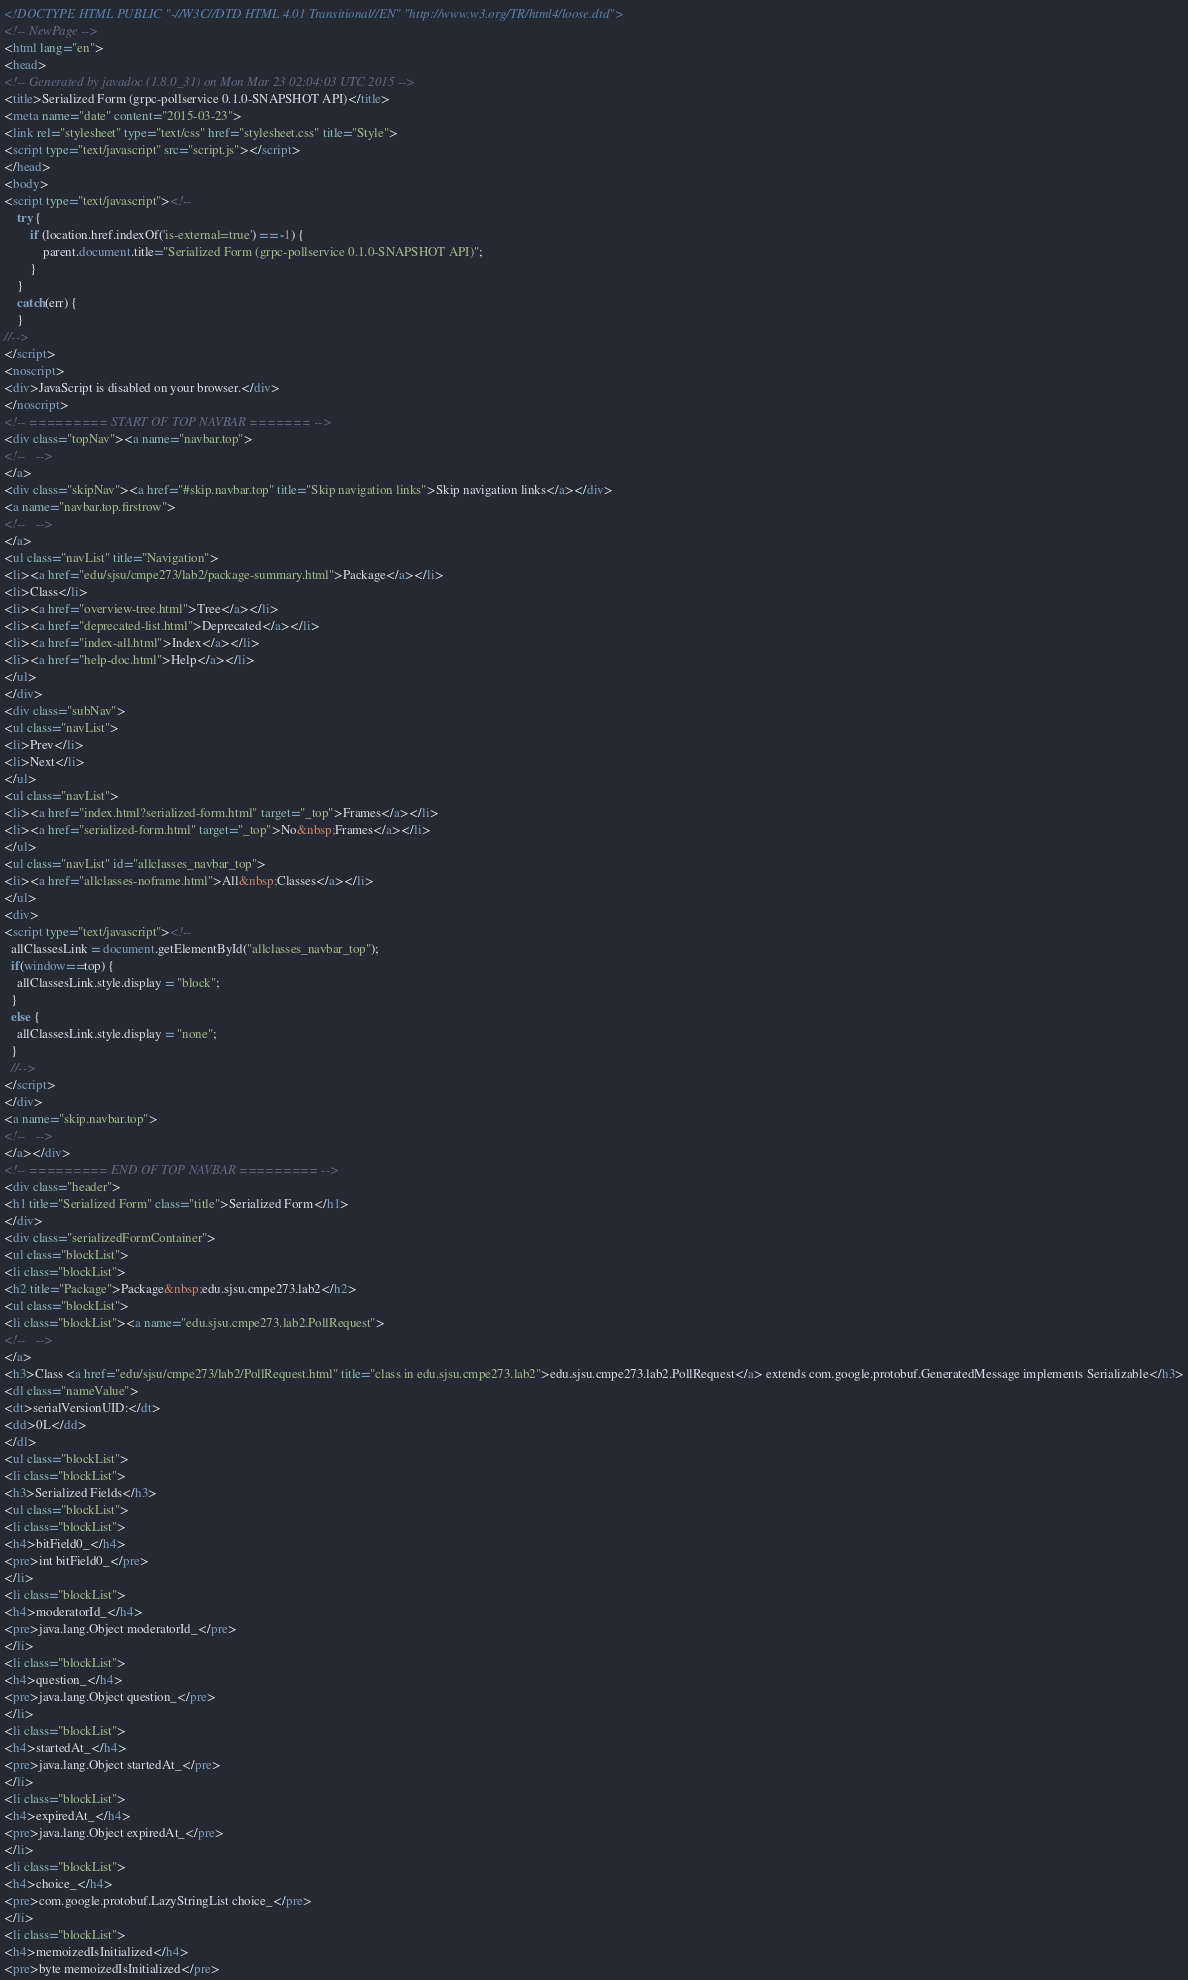Convert code to text. <code><loc_0><loc_0><loc_500><loc_500><_HTML_><!DOCTYPE HTML PUBLIC "-//W3C//DTD HTML 4.01 Transitional//EN" "http://www.w3.org/TR/html4/loose.dtd">
<!-- NewPage -->
<html lang="en">
<head>
<!-- Generated by javadoc (1.8.0_31) on Mon Mar 23 02:04:03 UTC 2015 -->
<title>Serialized Form (grpc-pollservice 0.1.0-SNAPSHOT API)</title>
<meta name="date" content="2015-03-23">
<link rel="stylesheet" type="text/css" href="stylesheet.css" title="Style">
<script type="text/javascript" src="script.js"></script>
</head>
<body>
<script type="text/javascript"><!--
    try {
        if (location.href.indexOf('is-external=true') == -1) {
            parent.document.title="Serialized Form (grpc-pollservice 0.1.0-SNAPSHOT API)";
        }
    }
    catch(err) {
    }
//-->
</script>
<noscript>
<div>JavaScript is disabled on your browser.</div>
</noscript>
<!-- ========= START OF TOP NAVBAR ======= -->
<div class="topNav"><a name="navbar.top">
<!--   -->
</a>
<div class="skipNav"><a href="#skip.navbar.top" title="Skip navigation links">Skip navigation links</a></div>
<a name="navbar.top.firstrow">
<!--   -->
</a>
<ul class="navList" title="Navigation">
<li><a href="edu/sjsu/cmpe273/lab2/package-summary.html">Package</a></li>
<li>Class</li>
<li><a href="overview-tree.html">Tree</a></li>
<li><a href="deprecated-list.html">Deprecated</a></li>
<li><a href="index-all.html">Index</a></li>
<li><a href="help-doc.html">Help</a></li>
</ul>
</div>
<div class="subNav">
<ul class="navList">
<li>Prev</li>
<li>Next</li>
</ul>
<ul class="navList">
<li><a href="index.html?serialized-form.html" target="_top">Frames</a></li>
<li><a href="serialized-form.html" target="_top">No&nbsp;Frames</a></li>
</ul>
<ul class="navList" id="allclasses_navbar_top">
<li><a href="allclasses-noframe.html">All&nbsp;Classes</a></li>
</ul>
<div>
<script type="text/javascript"><!--
  allClassesLink = document.getElementById("allclasses_navbar_top");
  if(window==top) {
    allClassesLink.style.display = "block";
  }
  else {
    allClassesLink.style.display = "none";
  }
  //-->
</script>
</div>
<a name="skip.navbar.top">
<!--   -->
</a></div>
<!-- ========= END OF TOP NAVBAR ========= -->
<div class="header">
<h1 title="Serialized Form" class="title">Serialized Form</h1>
</div>
<div class="serializedFormContainer">
<ul class="blockList">
<li class="blockList">
<h2 title="Package">Package&nbsp;edu.sjsu.cmpe273.lab2</h2>
<ul class="blockList">
<li class="blockList"><a name="edu.sjsu.cmpe273.lab2.PollRequest">
<!--   -->
</a>
<h3>Class <a href="edu/sjsu/cmpe273/lab2/PollRequest.html" title="class in edu.sjsu.cmpe273.lab2">edu.sjsu.cmpe273.lab2.PollRequest</a> extends com.google.protobuf.GeneratedMessage implements Serializable</h3>
<dl class="nameValue">
<dt>serialVersionUID:</dt>
<dd>0L</dd>
</dl>
<ul class="blockList">
<li class="blockList">
<h3>Serialized Fields</h3>
<ul class="blockList">
<li class="blockList">
<h4>bitField0_</h4>
<pre>int bitField0_</pre>
</li>
<li class="blockList">
<h4>moderatorId_</h4>
<pre>java.lang.Object moderatorId_</pre>
</li>
<li class="blockList">
<h4>question_</h4>
<pre>java.lang.Object question_</pre>
</li>
<li class="blockList">
<h4>startedAt_</h4>
<pre>java.lang.Object startedAt_</pre>
</li>
<li class="blockList">
<h4>expiredAt_</h4>
<pre>java.lang.Object expiredAt_</pre>
</li>
<li class="blockList">
<h4>choice_</h4>
<pre>com.google.protobuf.LazyStringList choice_</pre>
</li>
<li class="blockList">
<h4>memoizedIsInitialized</h4>
<pre>byte memoizedIsInitialized</pre></code> 